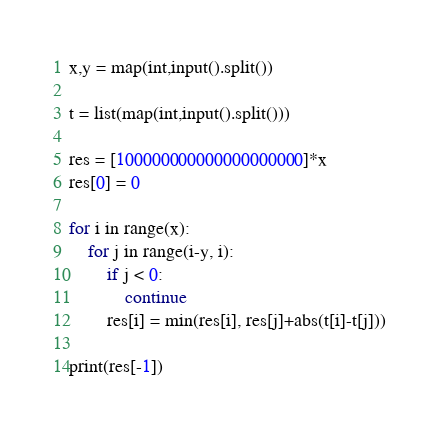<code> <loc_0><loc_0><loc_500><loc_500><_Python_>x,y = map(int,input().split())
 
t = list(map(int,input().split()))
 
res = [100000000000000000000]*x
res[0] = 0
 
for i in range(x):
    for j in range(i-y, i):
        if j < 0:
            continue
        res[i] = min(res[i], res[j]+abs(t[i]-t[j]))
 
print(res[-1])</code> 